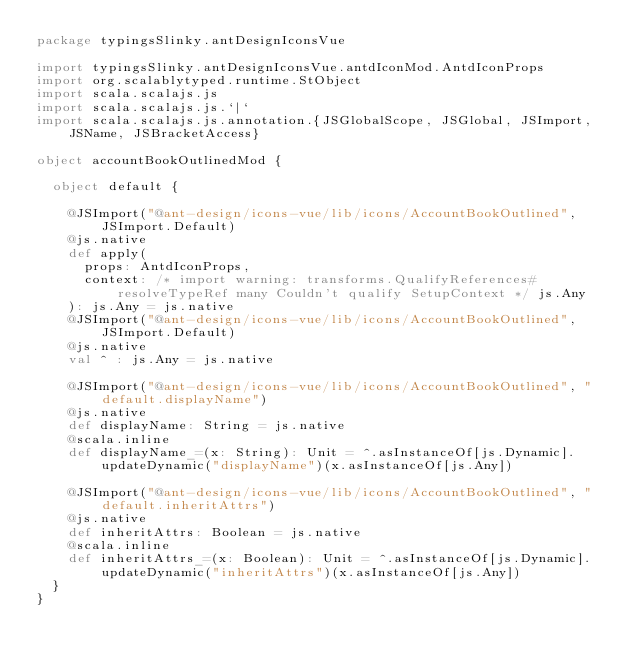<code> <loc_0><loc_0><loc_500><loc_500><_Scala_>package typingsSlinky.antDesignIconsVue

import typingsSlinky.antDesignIconsVue.antdIconMod.AntdIconProps
import org.scalablytyped.runtime.StObject
import scala.scalajs.js
import scala.scalajs.js.`|`
import scala.scalajs.js.annotation.{JSGlobalScope, JSGlobal, JSImport, JSName, JSBracketAccess}

object accountBookOutlinedMod {
  
  object default {
    
    @JSImport("@ant-design/icons-vue/lib/icons/AccountBookOutlined", JSImport.Default)
    @js.native
    def apply(
      props: AntdIconProps,
      context: /* import warning: transforms.QualifyReferences#resolveTypeRef many Couldn't qualify SetupContext */ js.Any
    ): js.Any = js.native
    @JSImport("@ant-design/icons-vue/lib/icons/AccountBookOutlined", JSImport.Default)
    @js.native
    val ^ : js.Any = js.native
    
    @JSImport("@ant-design/icons-vue/lib/icons/AccountBookOutlined", "default.displayName")
    @js.native
    def displayName: String = js.native
    @scala.inline
    def displayName_=(x: String): Unit = ^.asInstanceOf[js.Dynamic].updateDynamic("displayName")(x.asInstanceOf[js.Any])
    
    @JSImport("@ant-design/icons-vue/lib/icons/AccountBookOutlined", "default.inheritAttrs")
    @js.native
    def inheritAttrs: Boolean = js.native
    @scala.inline
    def inheritAttrs_=(x: Boolean): Unit = ^.asInstanceOf[js.Dynamic].updateDynamic("inheritAttrs")(x.asInstanceOf[js.Any])
  }
}
</code> 